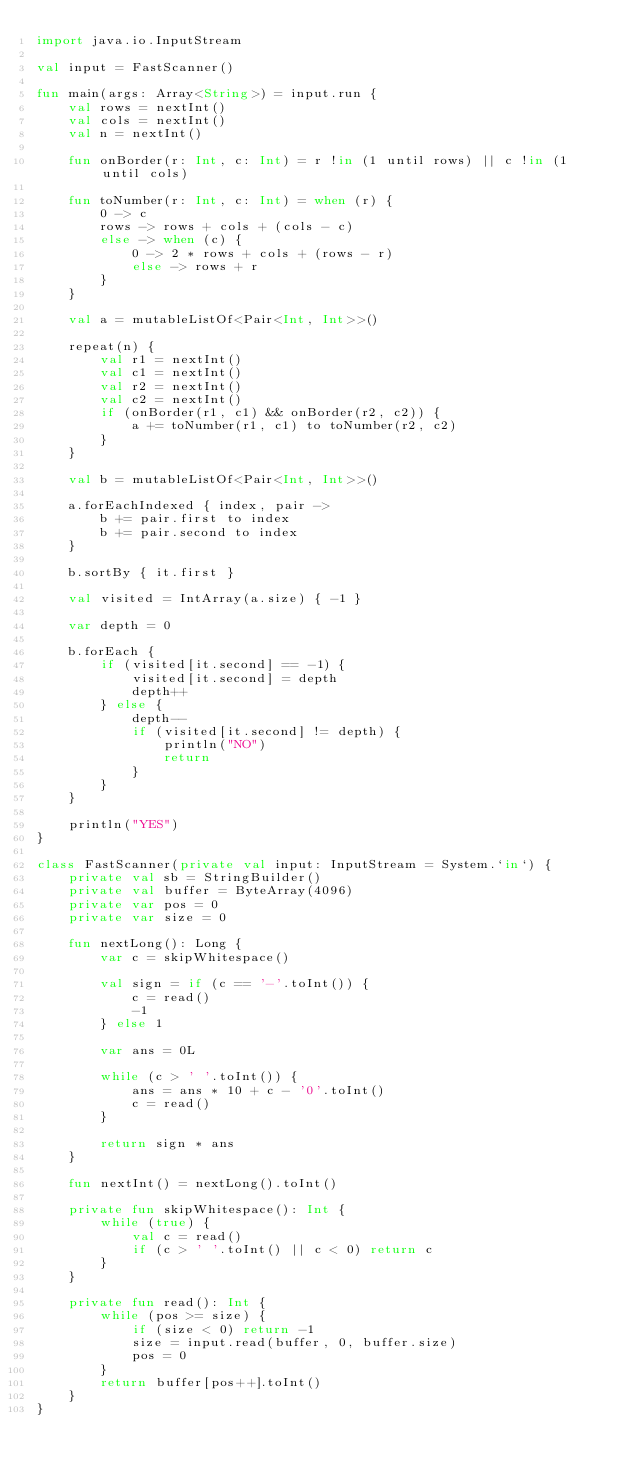Convert code to text. <code><loc_0><loc_0><loc_500><loc_500><_Kotlin_>import java.io.InputStream

val input = FastScanner()

fun main(args: Array<String>) = input.run {
    val rows = nextInt()
    val cols = nextInt()
    val n = nextInt()

    fun onBorder(r: Int, c: Int) = r !in (1 until rows) || c !in (1 until cols)

    fun toNumber(r: Int, c: Int) = when (r) {
        0 -> c
        rows -> rows + cols + (cols - c)
        else -> when (c) {
            0 -> 2 * rows + cols + (rows - r)
            else -> rows + r
        }
    }

    val a = mutableListOf<Pair<Int, Int>>()

    repeat(n) {
        val r1 = nextInt()
        val c1 = nextInt()
        val r2 = nextInt()
        val c2 = nextInt()
        if (onBorder(r1, c1) && onBorder(r2, c2)) {
            a += toNumber(r1, c1) to toNumber(r2, c2)
        }
    }

    val b = mutableListOf<Pair<Int, Int>>()

    a.forEachIndexed { index, pair ->
        b += pair.first to index
        b += pair.second to index
    }

    b.sortBy { it.first }

    val visited = IntArray(a.size) { -1 }

    var depth = 0

    b.forEach {
        if (visited[it.second] == -1) {
            visited[it.second] = depth
            depth++
        } else {
            depth--
            if (visited[it.second] != depth) {
                println("NO")
                return
            }
        }
    }

    println("YES")
}

class FastScanner(private val input: InputStream = System.`in`) {
    private val sb = StringBuilder()
    private val buffer = ByteArray(4096)
    private var pos = 0
    private var size = 0

    fun nextLong(): Long {
        var c = skipWhitespace()

        val sign = if (c == '-'.toInt()) {
            c = read()
            -1
        } else 1

        var ans = 0L

        while (c > ' '.toInt()) {
            ans = ans * 10 + c - '0'.toInt()
            c = read()
        }

        return sign * ans
    }

    fun nextInt() = nextLong().toInt()

    private fun skipWhitespace(): Int {
        while (true) {
            val c = read()
            if (c > ' '.toInt() || c < 0) return c
        }
    }

    private fun read(): Int {
        while (pos >= size) {
            if (size < 0) return -1
            size = input.read(buffer, 0, buffer.size)
            pos = 0
        }
        return buffer[pos++].toInt()
    }
}</code> 